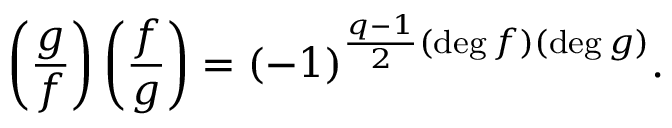Convert formula to latex. <formula><loc_0><loc_0><loc_500><loc_500>\left ( { \frac { g } { f } } \right ) \left ( { \frac { f } { g } } \right ) = ( - 1 ) ^ { { \frac { q - 1 } { 2 } } ( \deg f ) ( \deg g ) } .</formula> 